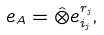Convert formula to latex. <formula><loc_0><loc_0><loc_500><loc_500>e _ { A } = \hat { \otimes } e _ { i _ { j } } ^ { r _ { j } } ,</formula> 